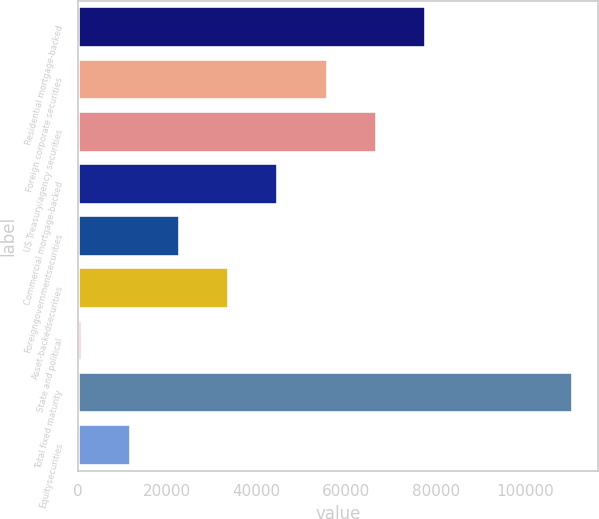<chart> <loc_0><loc_0><loc_500><loc_500><bar_chart><fcel>Residential mortgage-backed<fcel>Foreign corporate securities<fcel>US Treasury/agency securities<fcel>Commercial mortgage-backed<fcel>Foreigngovernmentsecurities<fcel>Asset-backedsecurities<fcel>State and political<fcel>Total fixed maturity<fcel>Equitysecurities<nl><fcel>77798.1<fcel>55817.5<fcel>66807.8<fcel>44827.2<fcel>22846.6<fcel>33836.9<fcel>866<fcel>110769<fcel>11856.3<nl></chart> 